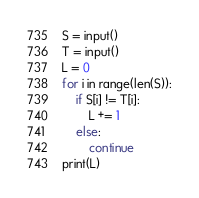Convert code to text. <code><loc_0><loc_0><loc_500><loc_500><_Python_>S = input()
T = input()
L = 0
for i in range(len(S)):
    if S[i] != T[i]:
        L += 1
    else:
        continue
print(L)

</code> 